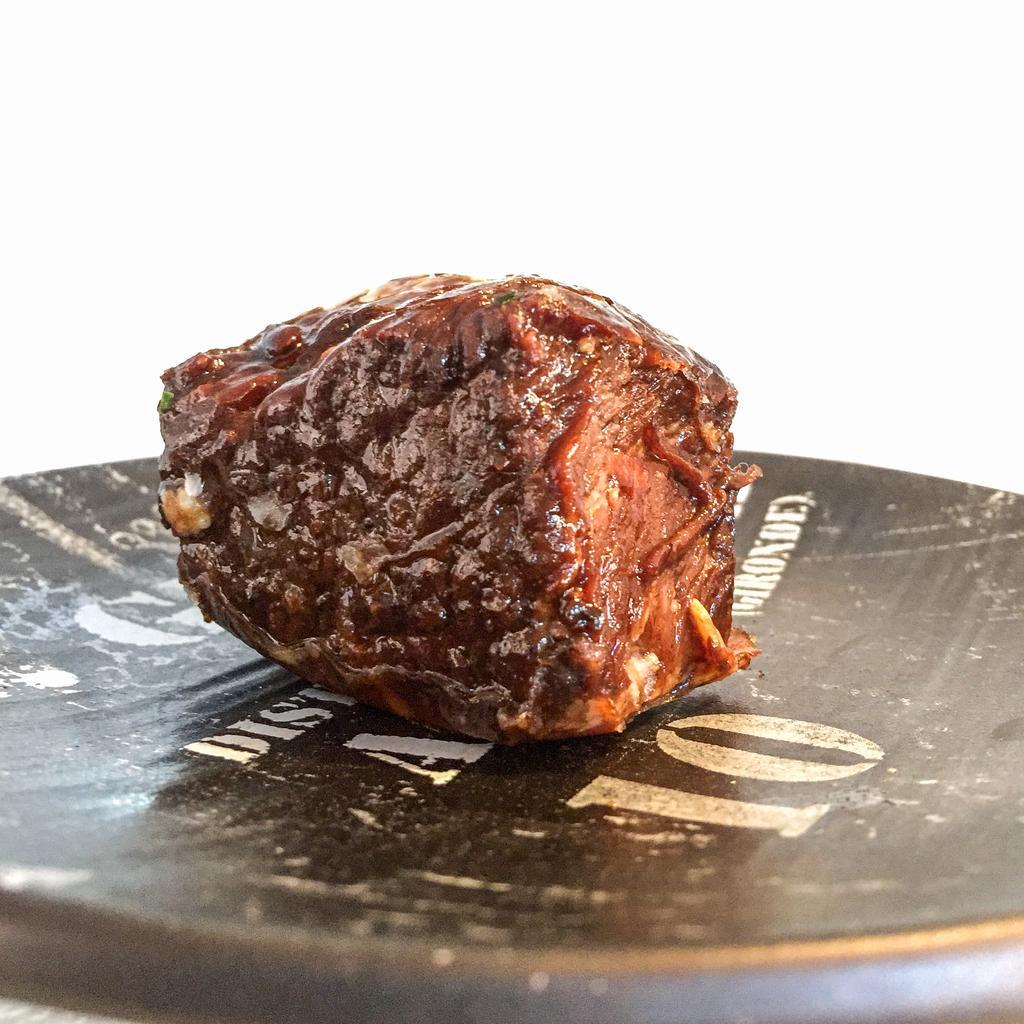Please provide a concise description of this image. In this picture I can see some food item placed on the plate. 